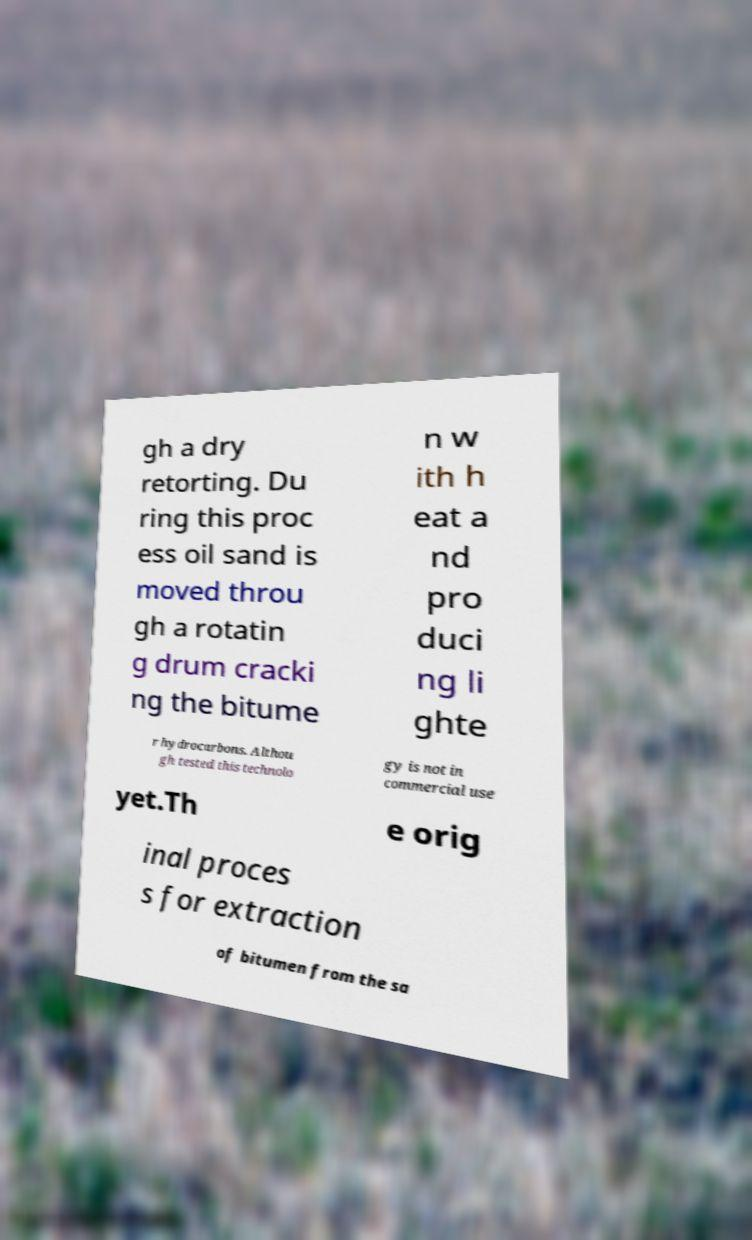I need the written content from this picture converted into text. Can you do that? gh a dry retorting. Du ring this proc ess oil sand is moved throu gh a rotatin g drum cracki ng the bitume n w ith h eat a nd pro duci ng li ghte r hydrocarbons. Althou gh tested this technolo gy is not in commercial use yet.Th e orig inal proces s for extraction of bitumen from the sa 